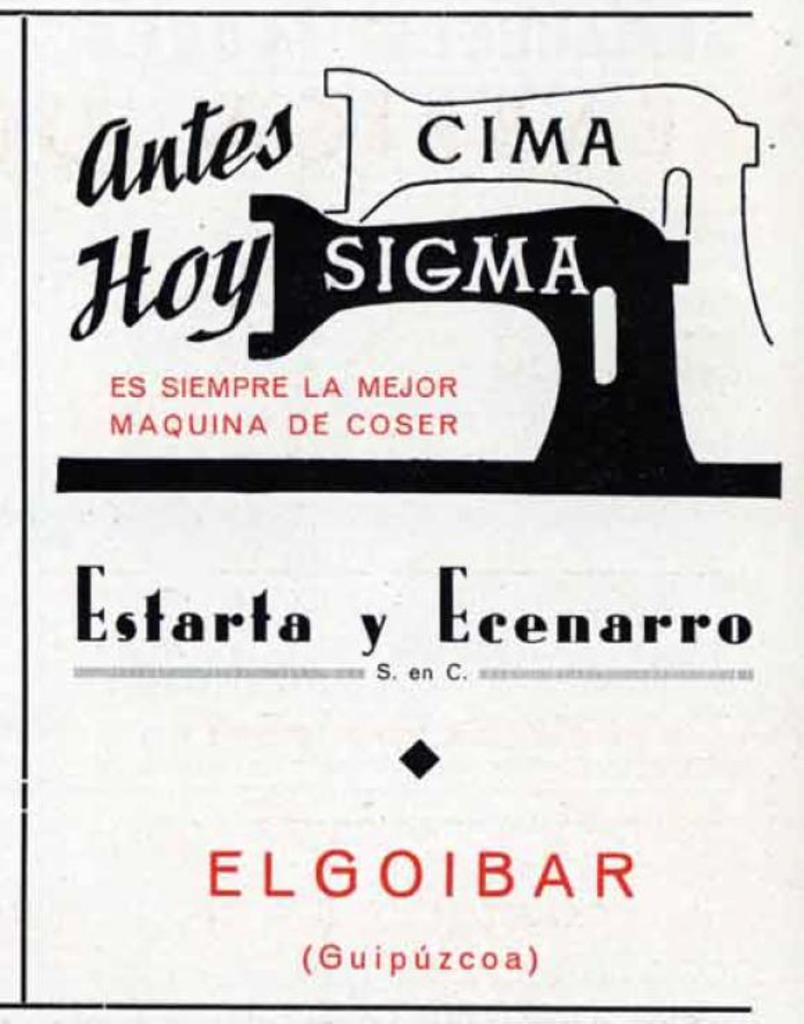Provide a one-sentence caption for the provided image. A poster that says Antes Cima How Sigma and Estarta y Ecenarro. 